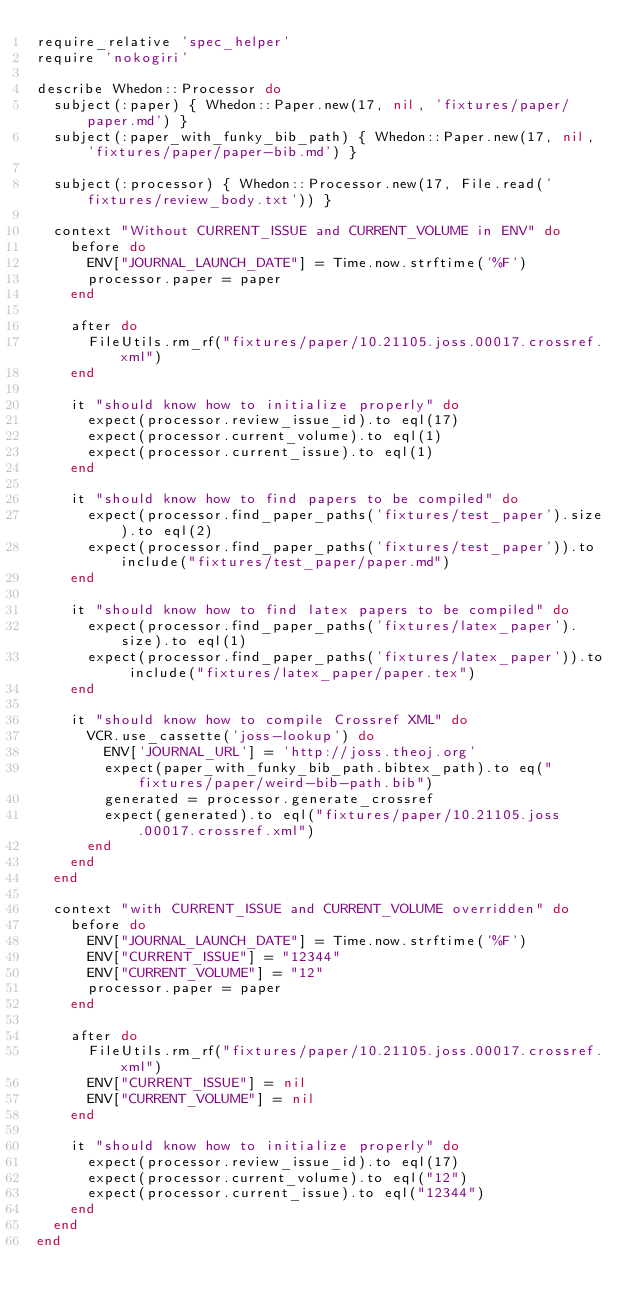Convert code to text. <code><loc_0><loc_0><loc_500><loc_500><_Ruby_>require_relative 'spec_helper'
require 'nokogiri'

describe Whedon::Processor do
  subject(:paper) { Whedon::Paper.new(17, nil, 'fixtures/paper/paper.md') }
  subject(:paper_with_funky_bib_path) { Whedon::Paper.new(17, nil, 'fixtures/paper/paper-bib.md') }

  subject(:processor) { Whedon::Processor.new(17, File.read('fixtures/review_body.txt')) }

  context "Without CURRENT_ISSUE and CURRENT_VOLUME in ENV" do
    before do
      ENV["JOURNAL_LAUNCH_DATE"] = Time.now.strftime('%F')
      processor.paper = paper
    end

    after do
      FileUtils.rm_rf("fixtures/paper/10.21105.joss.00017.crossref.xml")
    end

    it "should know how to initialize properly" do
      expect(processor.review_issue_id).to eql(17)
      expect(processor.current_volume).to eql(1)
      expect(processor.current_issue).to eql(1)
    end

    it "should know how to find papers to be compiled" do
      expect(processor.find_paper_paths('fixtures/test_paper').size).to eql(2)
      expect(processor.find_paper_paths('fixtures/test_paper')).to include("fixtures/test_paper/paper.md")
    end

    it "should know how to find latex papers to be compiled" do
      expect(processor.find_paper_paths('fixtures/latex_paper').size).to eql(1)
      expect(processor.find_paper_paths('fixtures/latex_paper')).to include("fixtures/latex_paper/paper.tex")
    end

    it "should know how to compile Crossref XML" do
      VCR.use_cassette('joss-lookup') do
        ENV['JOURNAL_URL'] = 'http://joss.theoj.org'
        expect(paper_with_funky_bib_path.bibtex_path).to eq("fixtures/paper/weird-bib-path.bib")
        generated = processor.generate_crossref
        expect(generated).to eql("fixtures/paper/10.21105.joss.00017.crossref.xml")
      end
    end
  end

  context "with CURRENT_ISSUE and CURRENT_VOLUME overridden" do
    before do
      ENV["JOURNAL_LAUNCH_DATE"] = Time.now.strftime('%F')
      ENV["CURRENT_ISSUE"] = "12344"
      ENV["CURRENT_VOLUME"] = "12"
      processor.paper = paper
    end

    after do
      FileUtils.rm_rf("fixtures/paper/10.21105.joss.00017.crossref.xml")
      ENV["CURRENT_ISSUE"] = nil
      ENV["CURRENT_VOLUME"] = nil
    end

    it "should know how to initialize properly" do
      expect(processor.review_issue_id).to eql(17)
      expect(processor.current_volume).to eql("12")
      expect(processor.current_issue).to eql("12344")
    end
  end
end
</code> 